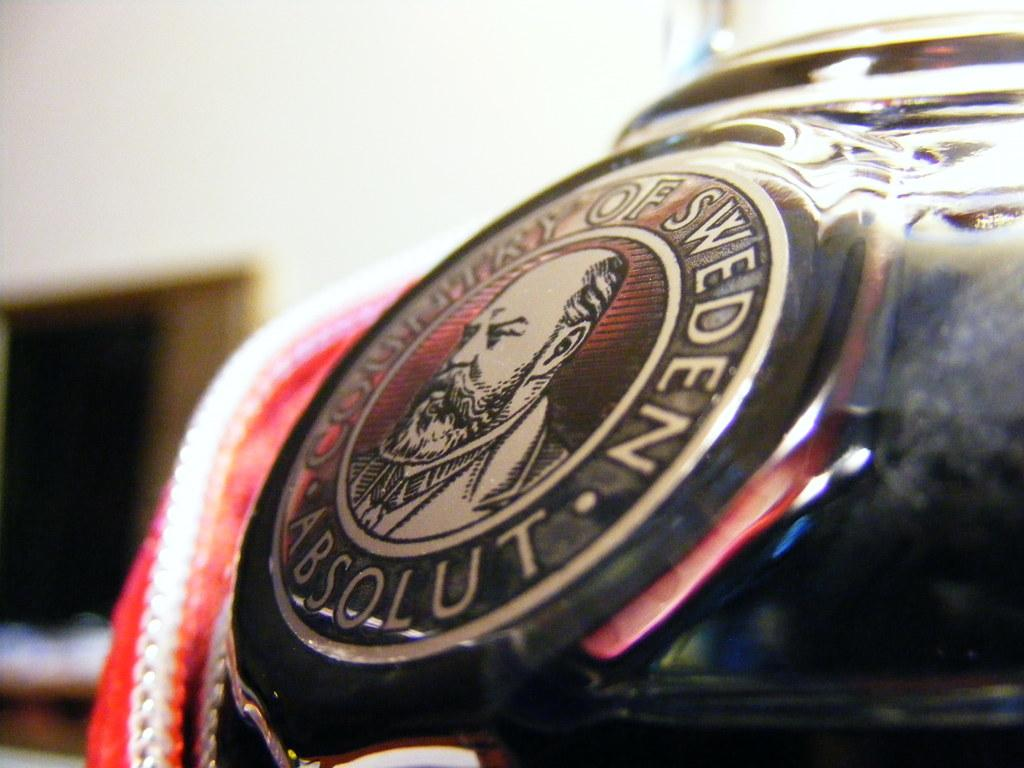What is the main subject of the image? There is a human picture in the image. What else can be seen around the human picture? There is text on a black object around the picture. How would you describe the background of the image? The background of the image has a blurred view. What color is present in the image? The color red is present in the image. How many trucks can be seen in the image? There are no trucks present in the image. What type of eye is visible in the image? There is no eye visible in the image; it features a human picture and text on a black object. 